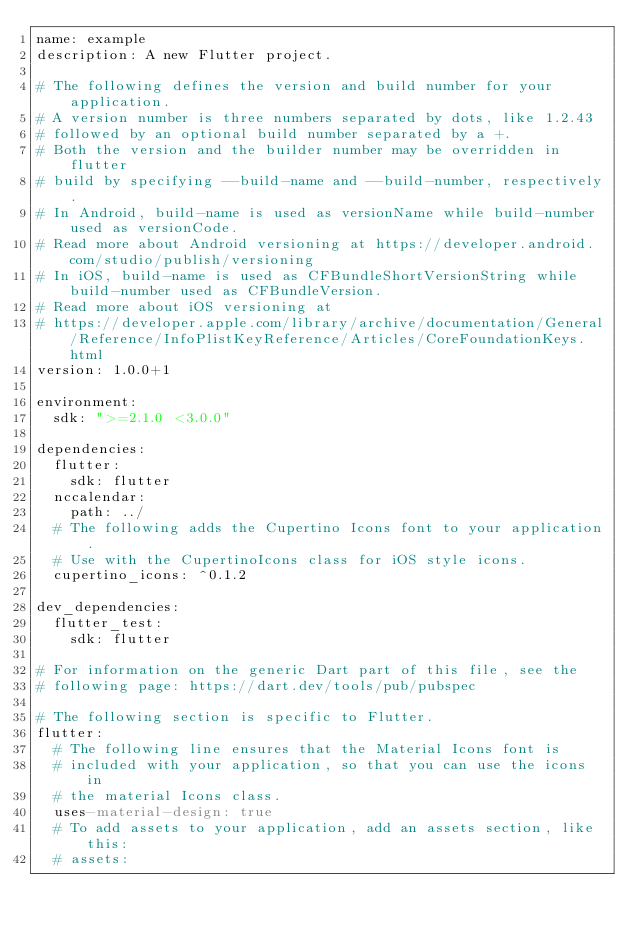Convert code to text. <code><loc_0><loc_0><loc_500><loc_500><_YAML_>name: example
description: A new Flutter project.

# The following defines the version and build number for your application.
# A version number is three numbers separated by dots, like 1.2.43
# followed by an optional build number separated by a +.
# Both the version and the builder number may be overridden in flutter
# build by specifying --build-name and --build-number, respectively.
# In Android, build-name is used as versionName while build-number used as versionCode.
# Read more about Android versioning at https://developer.android.com/studio/publish/versioning
# In iOS, build-name is used as CFBundleShortVersionString while build-number used as CFBundleVersion.
# Read more about iOS versioning at
# https://developer.apple.com/library/archive/documentation/General/Reference/InfoPlistKeyReference/Articles/CoreFoundationKeys.html
version: 1.0.0+1

environment:
  sdk: ">=2.1.0 <3.0.0"

dependencies:
  flutter:
    sdk: flutter
  nccalendar:
    path: ../
  # The following adds the Cupertino Icons font to your application.
  # Use with the CupertinoIcons class for iOS style icons.
  cupertino_icons: ^0.1.2

dev_dependencies:
  flutter_test:
    sdk: flutter

# For information on the generic Dart part of this file, see the
# following page: https://dart.dev/tools/pub/pubspec

# The following section is specific to Flutter.
flutter:
  # The following line ensures that the Material Icons font is
  # included with your application, so that you can use the icons in
  # the material Icons class.
  uses-material-design: true
  # To add assets to your application, add an assets section, like this:
  # assets:</code> 